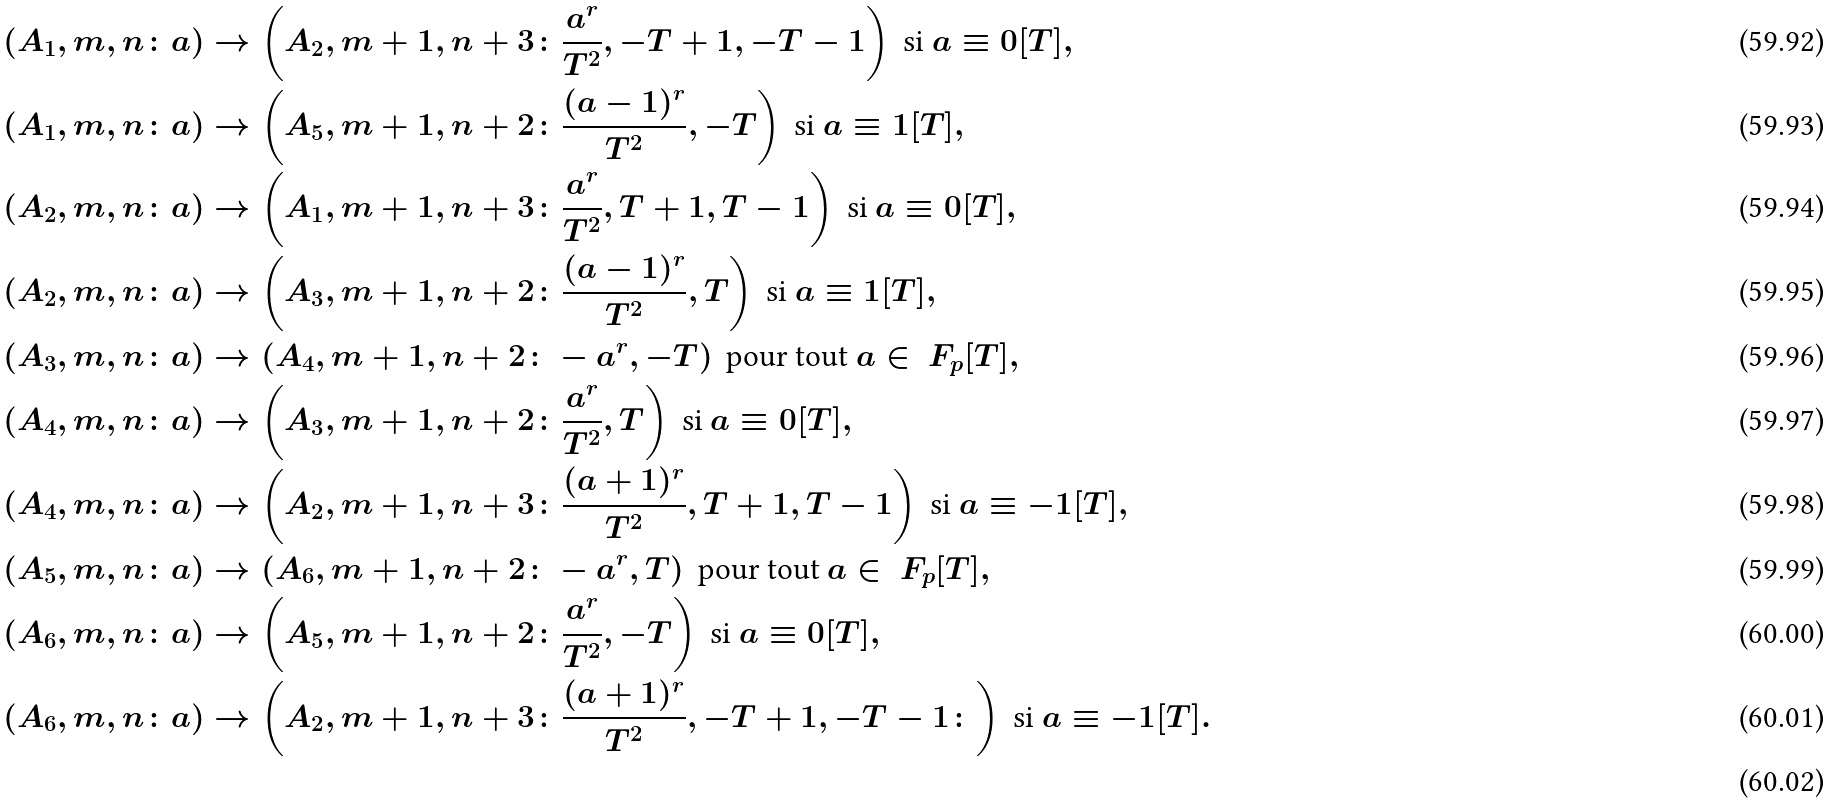<formula> <loc_0><loc_0><loc_500><loc_500>( A _ { 1 } , m , n \colon a ) & \rightarrow \left ( A _ { 2 } , m + 1 , n + 3 \colon \frac { a ^ { r } } { T ^ { 2 } } , - T + 1 , - T - 1 \right ) \text { si } a \equiv 0 [ T ] , \\ ( A _ { 1 } , m , n \colon a ) & \rightarrow \left ( A _ { 5 } , m + 1 , n + 2 \colon \frac { ( a - 1 ) ^ { r } } { T ^ { 2 } } , - T \right ) \text { si } a \equiv 1 [ T ] , \\ ( A _ { 2 } , m , n \colon a ) & \rightarrow \left ( A _ { 1 } , m + 1 , n + 3 \colon \frac { a ^ { r } } { T ^ { 2 } } , T + 1 , T - 1 \right ) \text { si } a \equiv 0 [ T ] , \\ ( A _ { 2 } , m , n \colon a ) & \rightarrow \left ( A _ { 3 } , m + 1 , n + 2 \colon \frac { ( a - 1 ) ^ { r } } { T ^ { 2 } } , T \right ) \text { si } a \equiv 1 [ T ] , \\ ( A _ { 3 } , m , n \colon a ) & \rightarrow \left ( A _ { 4 } , m + 1 , n + 2 \colon - a ^ { r } , - T \right ) \text { pour tout } a \in \ F _ { p } [ T ] , \\ ( A _ { 4 } , m , n \colon a ) & \rightarrow \left ( A _ { 3 } , m + 1 , n + 2 \colon \frac { a ^ { r } } { T ^ { 2 } } , T \right ) \text { si } a \equiv 0 [ T ] , \\ ( A _ { 4 } , m , n \colon a ) & \rightarrow \left ( A _ { 2 } , m + 1 , n + 3 \colon \frac { ( a + 1 ) ^ { r } } { T ^ { 2 } } , T + 1 , T - 1 \right ) \text { si } a \equiv - 1 [ T ] , \\ ( A _ { 5 } , m , n \colon a ) & \rightarrow \left ( A _ { 6 } , m + 1 , n + 2 \colon - a ^ { r } , T \right ) \text { pour tout } a \in \ F _ { p } [ T ] , \\ ( A _ { 6 } , m , n \colon a ) & \rightarrow \left ( A _ { 5 } , m + 1 , n + 2 \colon \frac { a ^ { r } } { T ^ { 2 } } , - T \right ) \text { si } a \equiv 0 [ T ] , \\ ( A _ { 6 } , m , n \colon a ) & \rightarrow \left ( A _ { 2 } , m + 1 , n + 3 \colon \frac { ( a + 1 ) ^ { r } } { T ^ { 2 } } , - T + 1 , - T - 1 \colon \right ) \text { si } a \equiv - 1 [ T ] . \\</formula> 